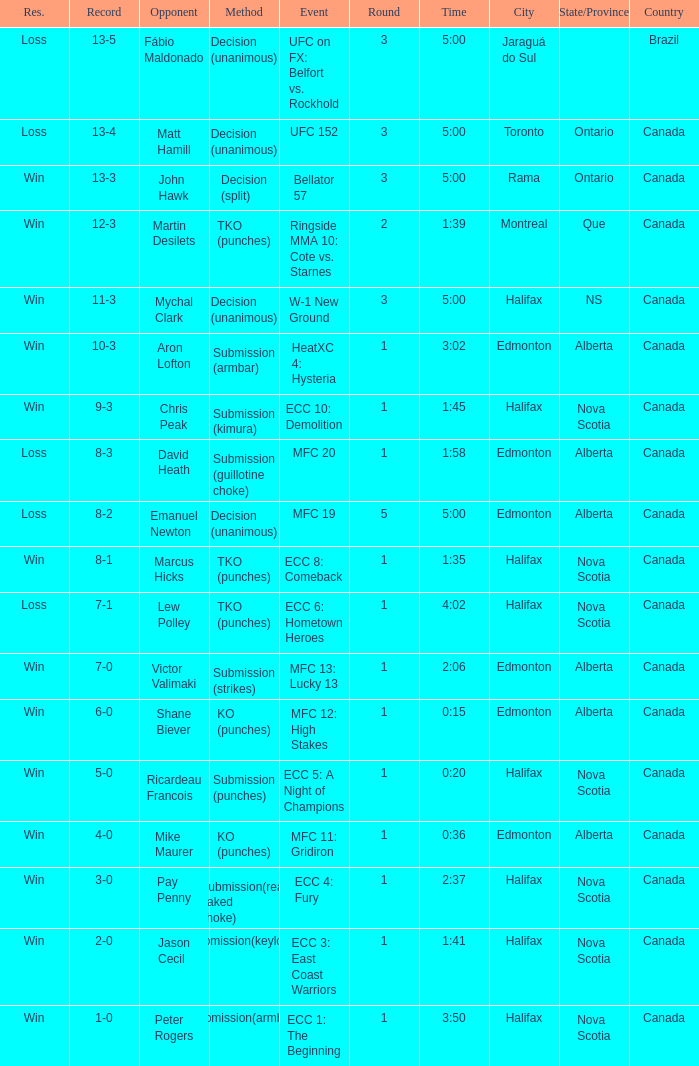What is the location of the match with an event of ecc 8: comeback? Halifax, Nova Scotia , Canada. 